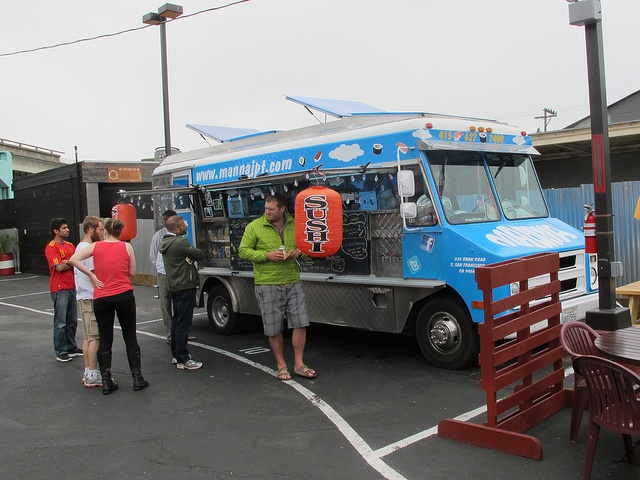Describe the objects in this image and their specific colors. I can see truck in lightgray, black, darkgray, and gray tones, people in lightgray, gray, darkgreen, black, and olive tones, people in lightgray, black, brown, and salmon tones, chair in lightgray, black, maroon, gray, and darkgray tones, and people in lightgray, black, gray, and darkgray tones in this image. 